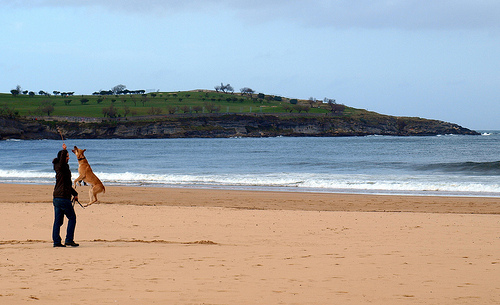What might be the weather conditions in the image? The weather in the image seems mild, indicated by the calm sea and the partly cloudy sky. The person on the beach is wearing long sleeves, which suggests a breezy or cool climate, appropriate for kite flying. There's sufficient wind to support kite flying, but not so strong as to churn the sea or bend trees on the headland. 